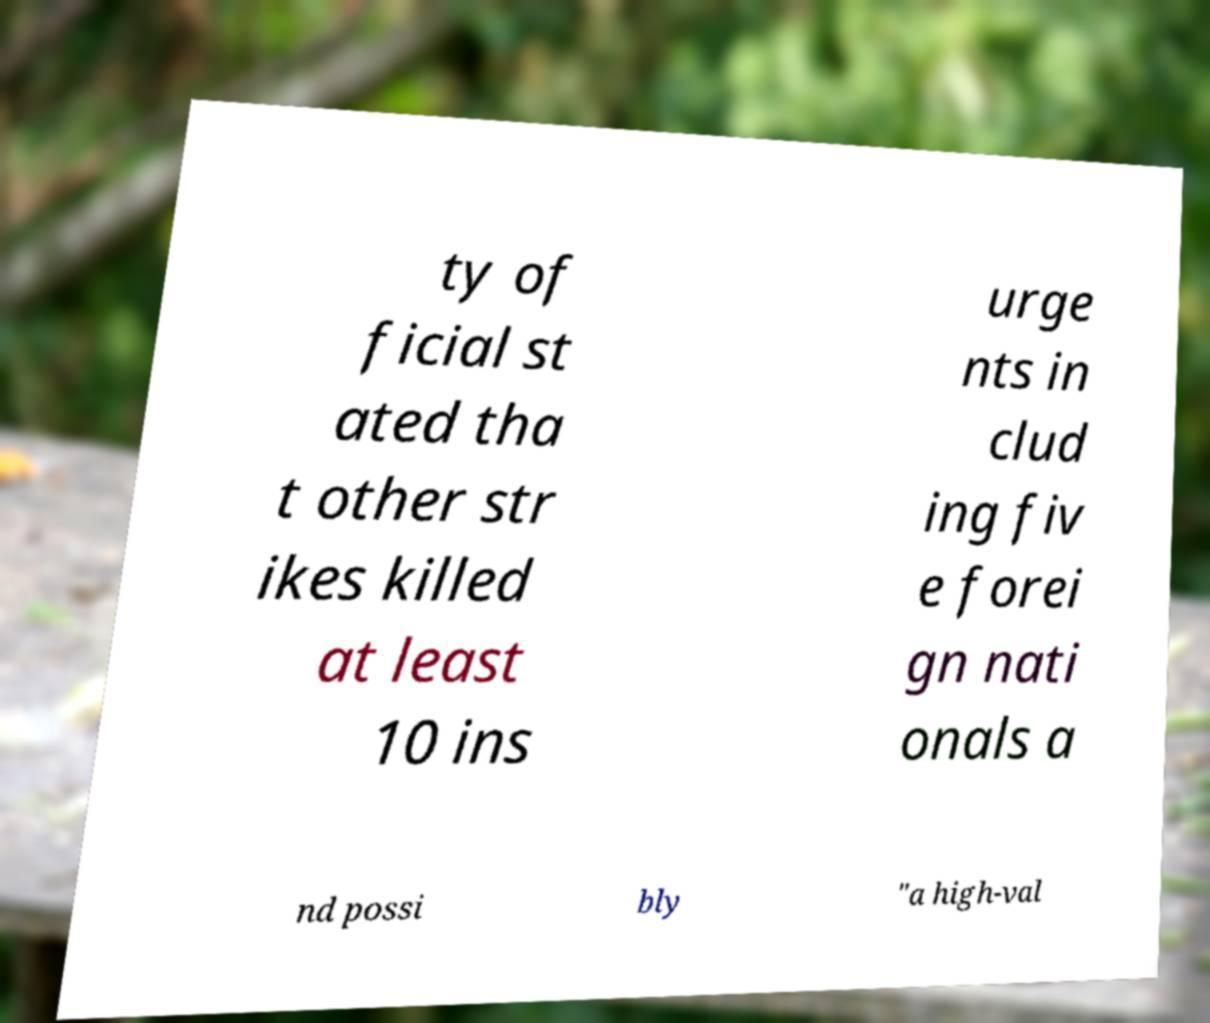There's text embedded in this image that I need extracted. Can you transcribe it verbatim? ty of ficial st ated tha t other str ikes killed at least 10 ins urge nts in clud ing fiv e forei gn nati onals a nd possi bly "a high-val 